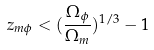Convert formula to latex. <formula><loc_0><loc_0><loc_500><loc_500>z _ { m \phi } < ( \frac { \Omega _ { \phi } } { \Omega _ { m } } ) ^ { 1 / 3 } - 1</formula> 